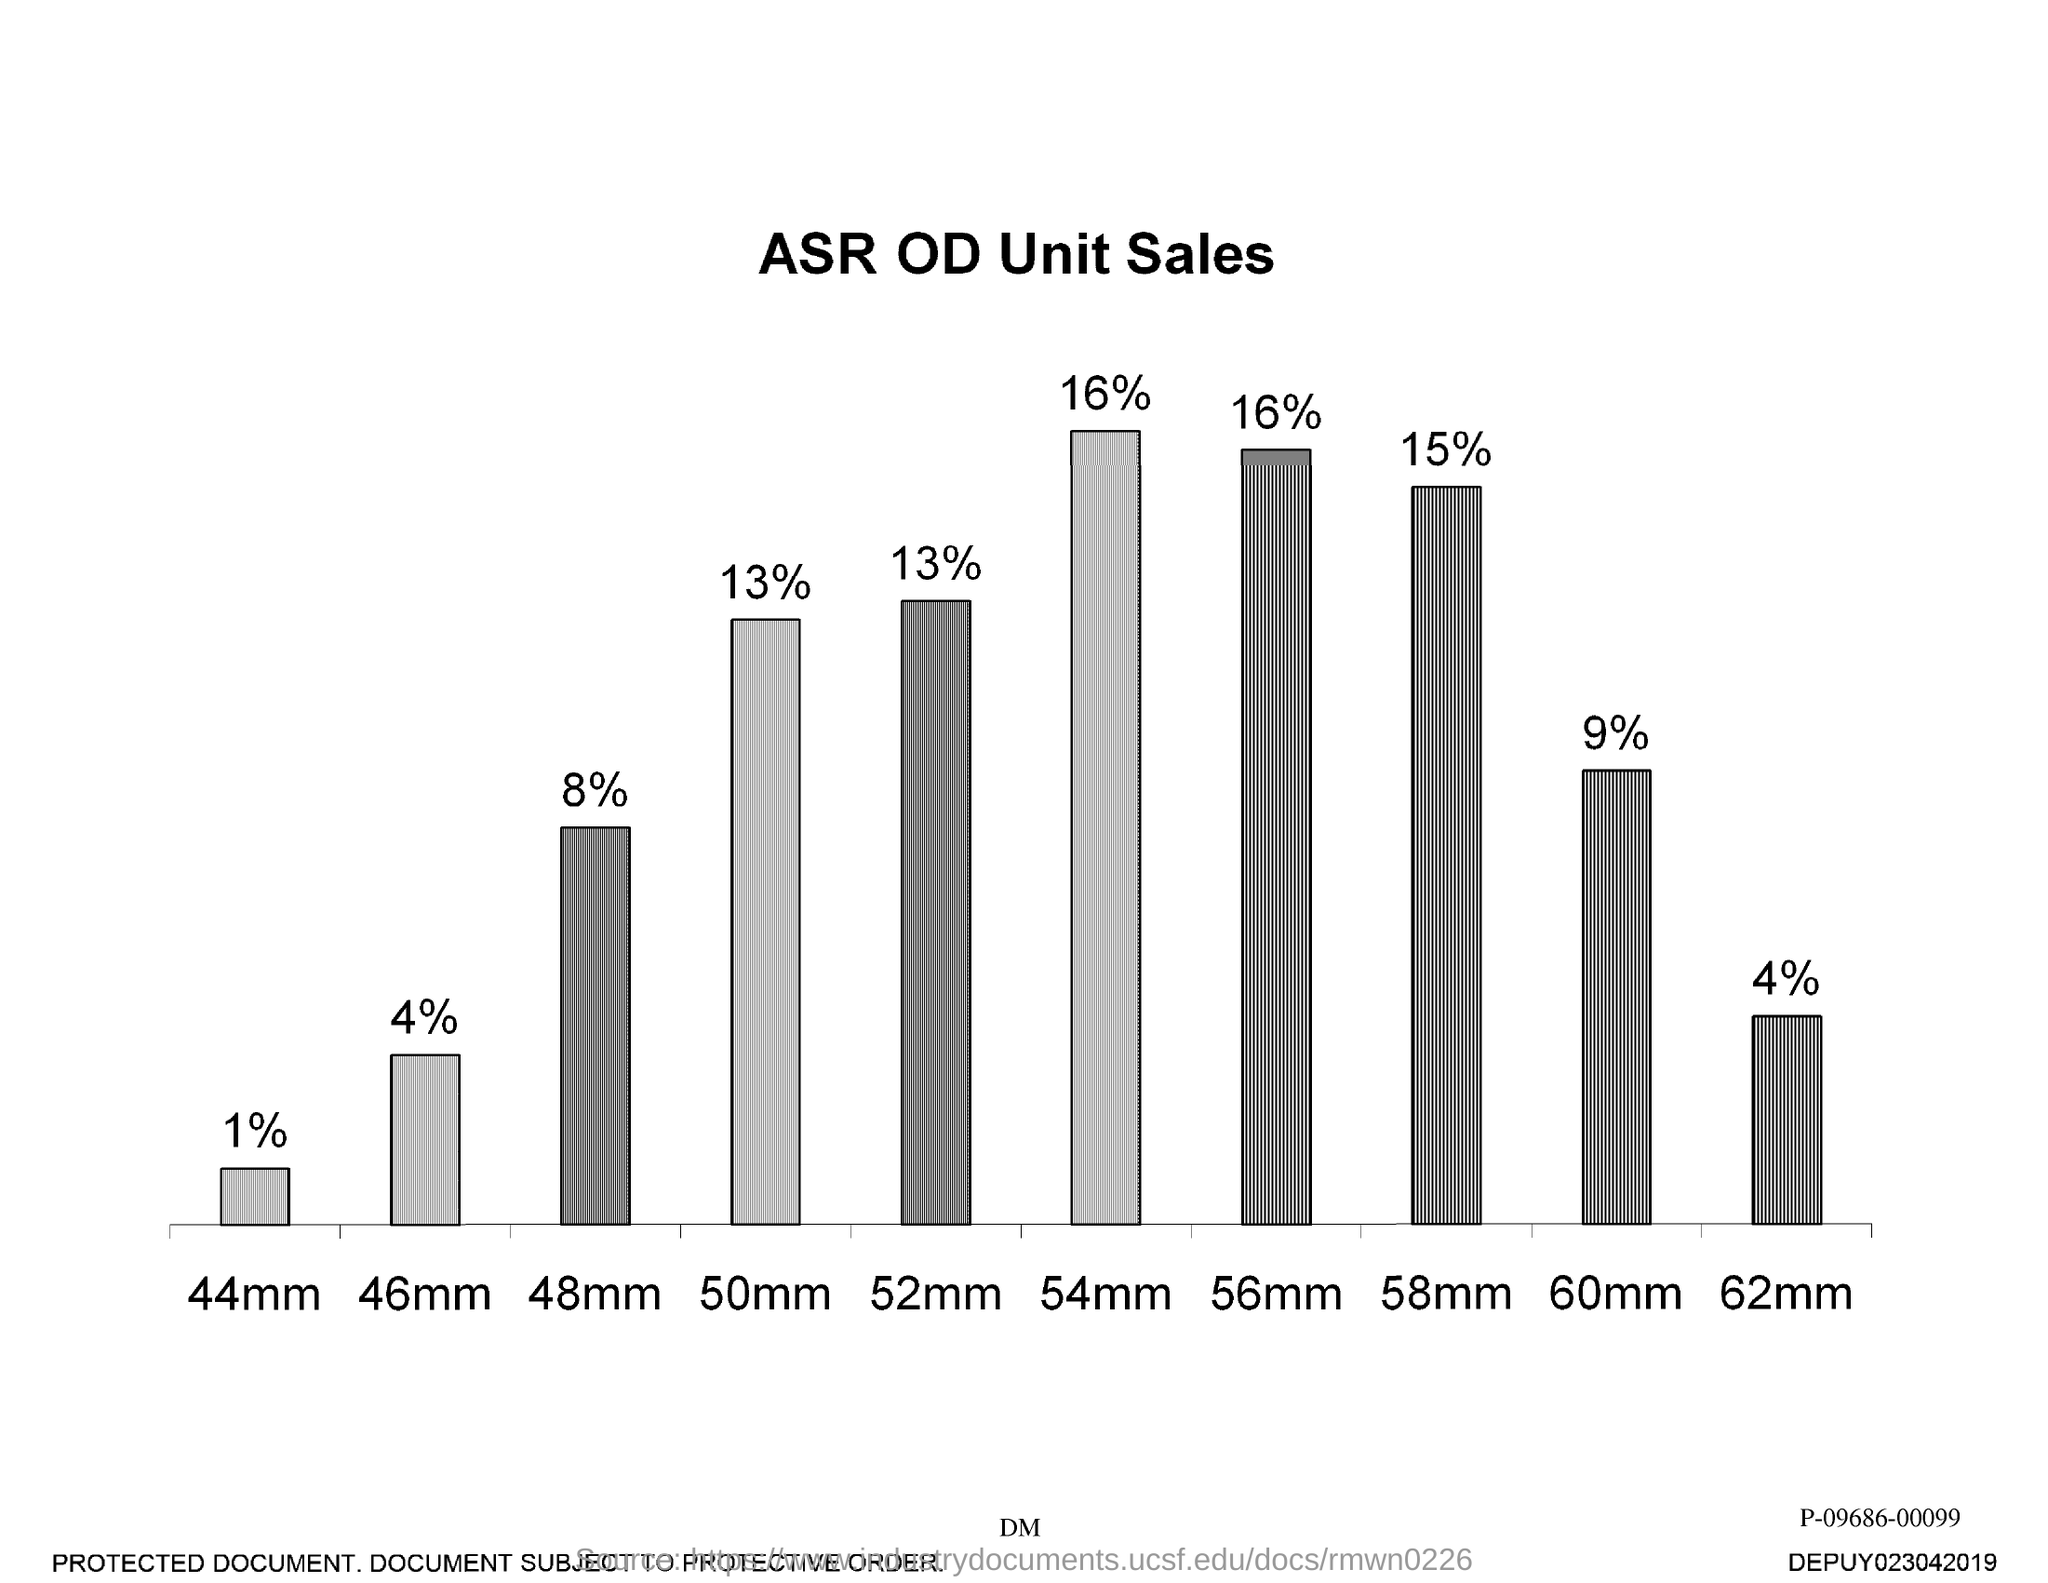Mention a couple of crucial points in this snapshot. The title of the graph is 'ASR OD Unit Sales.' 